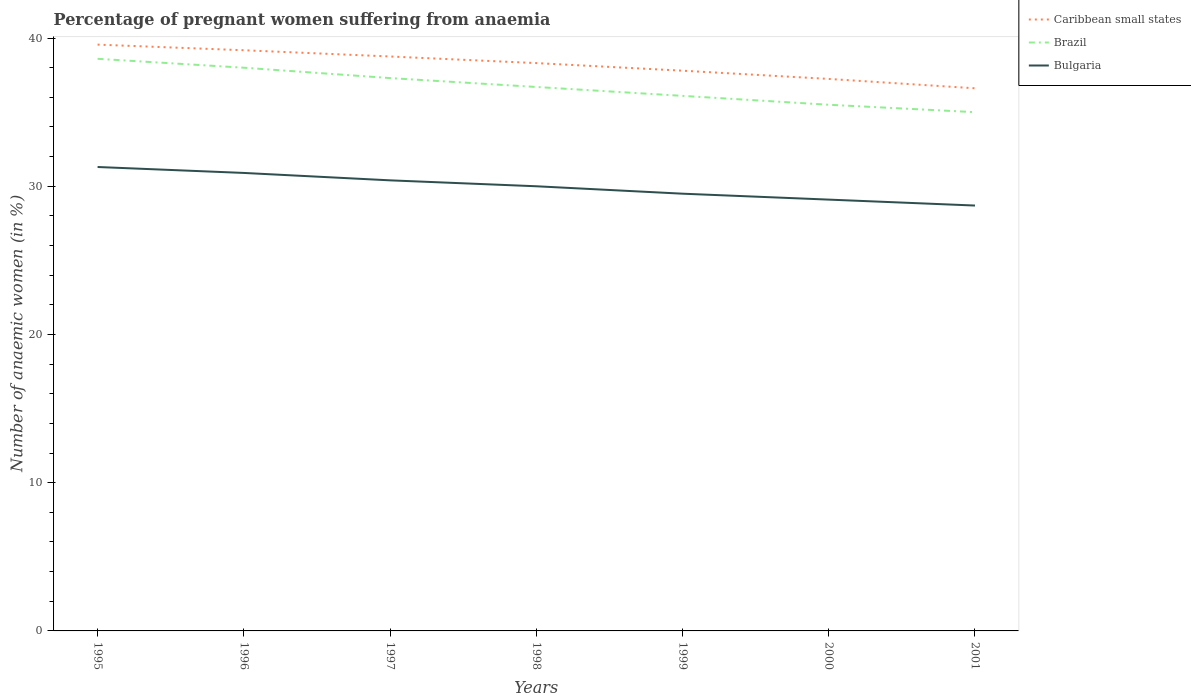How many different coloured lines are there?
Keep it short and to the point. 3. Across all years, what is the maximum number of anaemic women in Bulgaria?
Your response must be concise. 28.7. What is the total number of anaemic women in Bulgaria in the graph?
Provide a short and direct response. 1.8. What is the difference between the highest and the second highest number of anaemic women in Caribbean small states?
Make the answer very short. 2.95. How many years are there in the graph?
Your answer should be very brief. 7. Are the values on the major ticks of Y-axis written in scientific E-notation?
Ensure brevity in your answer.  No. What is the title of the graph?
Offer a terse response. Percentage of pregnant women suffering from anaemia. Does "San Marino" appear as one of the legend labels in the graph?
Offer a terse response. No. What is the label or title of the X-axis?
Offer a very short reply. Years. What is the label or title of the Y-axis?
Ensure brevity in your answer.  Number of anaemic women (in %). What is the Number of anaemic women (in %) in Caribbean small states in 1995?
Give a very brief answer. 39.56. What is the Number of anaemic women (in %) of Brazil in 1995?
Offer a terse response. 38.6. What is the Number of anaemic women (in %) in Bulgaria in 1995?
Ensure brevity in your answer.  31.3. What is the Number of anaemic women (in %) of Caribbean small states in 1996?
Ensure brevity in your answer.  39.18. What is the Number of anaemic women (in %) in Brazil in 1996?
Keep it short and to the point. 38. What is the Number of anaemic women (in %) in Bulgaria in 1996?
Offer a very short reply. 30.9. What is the Number of anaemic women (in %) in Caribbean small states in 1997?
Make the answer very short. 38.76. What is the Number of anaemic women (in %) in Brazil in 1997?
Offer a terse response. 37.3. What is the Number of anaemic women (in %) in Bulgaria in 1997?
Offer a terse response. 30.4. What is the Number of anaemic women (in %) in Caribbean small states in 1998?
Your response must be concise. 38.31. What is the Number of anaemic women (in %) of Brazil in 1998?
Keep it short and to the point. 36.7. What is the Number of anaemic women (in %) in Bulgaria in 1998?
Keep it short and to the point. 30. What is the Number of anaemic women (in %) of Caribbean small states in 1999?
Give a very brief answer. 37.8. What is the Number of anaemic women (in %) in Brazil in 1999?
Keep it short and to the point. 36.1. What is the Number of anaemic women (in %) in Bulgaria in 1999?
Offer a terse response. 29.5. What is the Number of anaemic women (in %) in Caribbean small states in 2000?
Offer a very short reply. 37.24. What is the Number of anaemic women (in %) in Brazil in 2000?
Keep it short and to the point. 35.5. What is the Number of anaemic women (in %) of Bulgaria in 2000?
Provide a succinct answer. 29.1. What is the Number of anaemic women (in %) of Caribbean small states in 2001?
Offer a terse response. 36.61. What is the Number of anaemic women (in %) in Brazil in 2001?
Keep it short and to the point. 35. What is the Number of anaemic women (in %) of Bulgaria in 2001?
Make the answer very short. 28.7. Across all years, what is the maximum Number of anaemic women (in %) in Caribbean small states?
Ensure brevity in your answer.  39.56. Across all years, what is the maximum Number of anaemic women (in %) in Brazil?
Make the answer very short. 38.6. Across all years, what is the maximum Number of anaemic women (in %) of Bulgaria?
Your answer should be very brief. 31.3. Across all years, what is the minimum Number of anaemic women (in %) of Caribbean small states?
Keep it short and to the point. 36.61. Across all years, what is the minimum Number of anaemic women (in %) in Bulgaria?
Provide a succinct answer. 28.7. What is the total Number of anaemic women (in %) in Caribbean small states in the graph?
Your answer should be very brief. 267.45. What is the total Number of anaemic women (in %) in Brazil in the graph?
Provide a succinct answer. 257.2. What is the total Number of anaemic women (in %) of Bulgaria in the graph?
Provide a short and direct response. 209.9. What is the difference between the Number of anaemic women (in %) of Caribbean small states in 1995 and that in 1996?
Offer a very short reply. 0.38. What is the difference between the Number of anaemic women (in %) in Brazil in 1995 and that in 1996?
Offer a terse response. 0.6. What is the difference between the Number of anaemic women (in %) in Caribbean small states in 1995 and that in 1997?
Ensure brevity in your answer.  0.8. What is the difference between the Number of anaemic women (in %) of Bulgaria in 1995 and that in 1997?
Provide a succinct answer. 0.9. What is the difference between the Number of anaemic women (in %) of Caribbean small states in 1995 and that in 1998?
Your response must be concise. 1.25. What is the difference between the Number of anaemic women (in %) in Brazil in 1995 and that in 1998?
Your answer should be very brief. 1.9. What is the difference between the Number of anaemic women (in %) of Caribbean small states in 1995 and that in 1999?
Give a very brief answer. 1.76. What is the difference between the Number of anaemic women (in %) of Caribbean small states in 1995 and that in 2000?
Make the answer very short. 2.31. What is the difference between the Number of anaemic women (in %) of Bulgaria in 1995 and that in 2000?
Keep it short and to the point. 2.2. What is the difference between the Number of anaemic women (in %) in Caribbean small states in 1995 and that in 2001?
Your answer should be very brief. 2.95. What is the difference between the Number of anaemic women (in %) of Bulgaria in 1995 and that in 2001?
Your response must be concise. 2.6. What is the difference between the Number of anaemic women (in %) of Caribbean small states in 1996 and that in 1997?
Your answer should be compact. 0.42. What is the difference between the Number of anaemic women (in %) in Caribbean small states in 1996 and that in 1998?
Your answer should be compact. 0.87. What is the difference between the Number of anaemic women (in %) in Brazil in 1996 and that in 1998?
Make the answer very short. 1.3. What is the difference between the Number of anaemic women (in %) in Caribbean small states in 1996 and that in 1999?
Your answer should be compact. 1.38. What is the difference between the Number of anaemic women (in %) of Caribbean small states in 1996 and that in 2000?
Offer a very short reply. 1.93. What is the difference between the Number of anaemic women (in %) of Caribbean small states in 1996 and that in 2001?
Keep it short and to the point. 2.57. What is the difference between the Number of anaemic women (in %) of Brazil in 1996 and that in 2001?
Keep it short and to the point. 3. What is the difference between the Number of anaemic women (in %) in Caribbean small states in 1997 and that in 1998?
Provide a short and direct response. 0.45. What is the difference between the Number of anaemic women (in %) of Brazil in 1997 and that in 1998?
Make the answer very short. 0.6. What is the difference between the Number of anaemic women (in %) in Caribbean small states in 1997 and that in 1999?
Your answer should be compact. 0.96. What is the difference between the Number of anaemic women (in %) of Brazil in 1997 and that in 1999?
Your answer should be very brief. 1.2. What is the difference between the Number of anaemic women (in %) in Caribbean small states in 1997 and that in 2000?
Give a very brief answer. 1.51. What is the difference between the Number of anaemic women (in %) of Brazil in 1997 and that in 2000?
Your answer should be compact. 1.8. What is the difference between the Number of anaemic women (in %) in Bulgaria in 1997 and that in 2000?
Give a very brief answer. 1.3. What is the difference between the Number of anaemic women (in %) of Caribbean small states in 1997 and that in 2001?
Your response must be concise. 2.15. What is the difference between the Number of anaemic women (in %) in Bulgaria in 1997 and that in 2001?
Your answer should be very brief. 1.7. What is the difference between the Number of anaemic women (in %) of Caribbean small states in 1998 and that in 1999?
Provide a succinct answer. 0.51. What is the difference between the Number of anaemic women (in %) of Bulgaria in 1998 and that in 1999?
Provide a succinct answer. 0.5. What is the difference between the Number of anaemic women (in %) of Caribbean small states in 1998 and that in 2000?
Offer a terse response. 1.07. What is the difference between the Number of anaemic women (in %) of Bulgaria in 1998 and that in 2000?
Offer a terse response. 0.9. What is the difference between the Number of anaemic women (in %) in Brazil in 1998 and that in 2001?
Your response must be concise. 1.7. What is the difference between the Number of anaemic women (in %) of Bulgaria in 1998 and that in 2001?
Provide a short and direct response. 1.3. What is the difference between the Number of anaemic women (in %) in Caribbean small states in 1999 and that in 2000?
Offer a very short reply. 0.56. What is the difference between the Number of anaemic women (in %) of Caribbean small states in 1999 and that in 2001?
Offer a very short reply. 1.19. What is the difference between the Number of anaemic women (in %) of Bulgaria in 1999 and that in 2001?
Offer a very short reply. 0.8. What is the difference between the Number of anaemic women (in %) of Caribbean small states in 2000 and that in 2001?
Make the answer very short. 0.63. What is the difference between the Number of anaemic women (in %) in Bulgaria in 2000 and that in 2001?
Provide a succinct answer. 0.4. What is the difference between the Number of anaemic women (in %) in Caribbean small states in 1995 and the Number of anaemic women (in %) in Brazil in 1996?
Ensure brevity in your answer.  1.56. What is the difference between the Number of anaemic women (in %) in Caribbean small states in 1995 and the Number of anaemic women (in %) in Bulgaria in 1996?
Your answer should be very brief. 8.66. What is the difference between the Number of anaemic women (in %) in Brazil in 1995 and the Number of anaemic women (in %) in Bulgaria in 1996?
Your response must be concise. 7.7. What is the difference between the Number of anaemic women (in %) of Caribbean small states in 1995 and the Number of anaemic women (in %) of Brazil in 1997?
Make the answer very short. 2.26. What is the difference between the Number of anaemic women (in %) of Caribbean small states in 1995 and the Number of anaemic women (in %) of Bulgaria in 1997?
Offer a very short reply. 9.16. What is the difference between the Number of anaemic women (in %) of Brazil in 1995 and the Number of anaemic women (in %) of Bulgaria in 1997?
Your response must be concise. 8.2. What is the difference between the Number of anaemic women (in %) in Caribbean small states in 1995 and the Number of anaemic women (in %) in Brazil in 1998?
Keep it short and to the point. 2.86. What is the difference between the Number of anaemic women (in %) of Caribbean small states in 1995 and the Number of anaemic women (in %) of Bulgaria in 1998?
Offer a terse response. 9.56. What is the difference between the Number of anaemic women (in %) in Caribbean small states in 1995 and the Number of anaemic women (in %) in Brazil in 1999?
Offer a terse response. 3.46. What is the difference between the Number of anaemic women (in %) in Caribbean small states in 1995 and the Number of anaemic women (in %) in Bulgaria in 1999?
Keep it short and to the point. 10.06. What is the difference between the Number of anaemic women (in %) of Brazil in 1995 and the Number of anaemic women (in %) of Bulgaria in 1999?
Provide a succinct answer. 9.1. What is the difference between the Number of anaemic women (in %) in Caribbean small states in 1995 and the Number of anaemic women (in %) in Brazil in 2000?
Your answer should be compact. 4.06. What is the difference between the Number of anaemic women (in %) in Caribbean small states in 1995 and the Number of anaemic women (in %) in Bulgaria in 2000?
Your response must be concise. 10.46. What is the difference between the Number of anaemic women (in %) of Brazil in 1995 and the Number of anaemic women (in %) of Bulgaria in 2000?
Offer a terse response. 9.5. What is the difference between the Number of anaemic women (in %) in Caribbean small states in 1995 and the Number of anaemic women (in %) in Brazil in 2001?
Offer a terse response. 4.56. What is the difference between the Number of anaemic women (in %) in Caribbean small states in 1995 and the Number of anaemic women (in %) in Bulgaria in 2001?
Provide a short and direct response. 10.86. What is the difference between the Number of anaemic women (in %) in Caribbean small states in 1996 and the Number of anaemic women (in %) in Brazil in 1997?
Your response must be concise. 1.88. What is the difference between the Number of anaemic women (in %) of Caribbean small states in 1996 and the Number of anaemic women (in %) of Bulgaria in 1997?
Keep it short and to the point. 8.78. What is the difference between the Number of anaemic women (in %) in Caribbean small states in 1996 and the Number of anaemic women (in %) in Brazil in 1998?
Provide a succinct answer. 2.48. What is the difference between the Number of anaemic women (in %) of Caribbean small states in 1996 and the Number of anaemic women (in %) of Bulgaria in 1998?
Provide a succinct answer. 9.18. What is the difference between the Number of anaemic women (in %) of Caribbean small states in 1996 and the Number of anaemic women (in %) of Brazil in 1999?
Keep it short and to the point. 3.08. What is the difference between the Number of anaemic women (in %) of Caribbean small states in 1996 and the Number of anaemic women (in %) of Bulgaria in 1999?
Provide a short and direct response. 9.68. What is the difference between the Number of anaemic women (in %) in Brazil in 1996 and the Number of anaemic women (in %) in Bulgaria in 1999?
Offer a very short reply. 8.5. What is the difference between the Number of anaemic women (in %) of Caribbean small states in 1996 and the Number of anaemic women (in %) of Brazil in 2000?
Give a very brief answer. 3.68. What is the difference between the Number of anaemic women (in %) of Caribbean small states in 1996 and the Number of anaemic women (in %) of Bulgaria in 2000?
Keep it short and to the point. 10.08. What is the difference between the Number of anaemic women (in %) in Brazil in 1996 and the Number of anaemic women (in %) in Bulgaria in 2000?
Make the answer very short. 8.9. What is the difference between the Number of anaemic women (in %) of Caribbean small states in 1996 and the Number of anaemic women (in %) of Brazil in 2001?
Your answer should be compact. 4.18. What is the difference between the Number of anaemic women (in %) of Caribbean small states in 1996 and the Number of anaemic women (in %) of Bulgaria in 2001?
Offer a very short reply. 10.48. What is the difference between the Number of anaemic women (in %) in Caribbean small states in 1997 and the Number of anaemic women (in %) in Brazil in 1998?
Make the answer very short. 2.06. What is the difference between the Number of anaemic women (in %) of Caribbean small states in 1997 and the Number of anaemic women (in %) of Bulgaria in 1998?
Your response must be concise. 8.76. What is the difference between the Number of anaemic women (in %) of Brazil in 1997 and the Number of anaemic women (in %) of Bulgaria in 1998?
Give a very brief answer. 7.3. What is the difference between the Number of anaemic women (in %) in Caribbean small states in 1997 and the Number of anaemic women (in %) in Brazil in 1999?
Make the answer very short. 2.66. What is the difference between the Number of anaemic women (in %) of Caribbean small states in 1997 and the Number of anaemic women (in %) of Bulgaria in 1999?
Provide a short and direct response. 9.26. What is the difference between the Number of anaemic women (in %) of Caribbean small states in 1997 and the Number of anaemic women (in %) of Brazil in 2000?
Your answer should be compact. 3.26. What is the difference between the Number of anaemic women (in %) of Caribbean small states in 1997 and the Number of anaemic women (in %) of Bulgaria in 2000?
Ensure brevity in your answer.  9.66. What is the difference between the Number of anaemic women (in %) of Brazil in 1997 and the Number of anaemic women (in %) of Bulgaria in 2000?
Ensure brevity in your answer.  8.2. What is the difference between the Number of anaemic women (in %) of Caribbean small states in 1997 and the Number of anaemic women (in %) of Brazil in 2001?
Offer a terse response. 3.76. What is the difference between the Number of anaemic women (in %) of Caribbean small states in 1997 and the Number of anaemic women (in %) of Bulgaria in 2001?
Offer a very short reply. 10.06. What is the difference between the Number of anaemic women (in %) in Brazil in 1997 and the Number of anaemic women (in %) in Bulgaria in 2001?
Make the answer very short. 8.6. What is the difference between the Number of anaemic women (in %) in Caribbean small states in 1998 and the Number of anaemic women (in %) in Brazil in 1999?
Make the answer very short. 2.21. What is the difference between the Number of anaemic women (in %) of Caribbean small states in 1998 and the Number of anaemic women (in %) of Bulgaria in 1999?
Give a very brief answer. 8.81. What is the difference between the Number of anaemic women (in %) in Brazil in 1998 and the Number of anaemic women (in %) in Bulgaria in 1999?
Your answer should be compact. 7.2. What is the difference between the Number of anaemic women (in %) in Caribbean small states in 1998 and the Number of anaemic women (in %) in Brazil in 2000?
Keep it short and to the point. 2.81. What is the difference between the Number of anaemic women (in %) of Caribbean small states in 1998 and the Number of anaemic women (in %) of Bulgaria in 2000?
Provide a short and direct response. 9.21. What is the difference between the Number of anaemic women (in %) of Caribbean small states in 1998 and the Number of anaemic women (in %) of Brazil in 2001?
Keep it short and to the point. 3.31. What is the difference between the Number of anaemic women (in %) in Caribbean small states in 1998 and the Number of anaemic women (in %) in Bulgaria in 2001?
Provide a succinct answer. 9.61. What is the difference between the Number of anaemic women (in %) of Caribbean small states in 1999 and the Number of anaemic women (in %) of Brazil in 2000?
Your response must be concise. 2.3. What is the difference between the Number of anaemic women (in %) of Caribbean small states in 1999 and the Number of anaemic women (in %) of Bulgaria in 2000?
Offer a terse response. 8.7. What is the difference between the Number of anaemic women (in %) of Caribbean small states in 1999 and the Number of anaemic women (in %) of Brazil in 2001?
Your response must be concise. 2.8. What is the difference between the Number of anaemic women (in %) in Caribbean small states in 1999 and the Number of anaemic women (in %) in Bulgaria in 2001?
Keep it short and to the point. 9.1. What is the difference between the Number of anaemic women (in %) of Caribbean small states in 2000 and the Number of anaemic women (in %) of Brazil in 2001?
Make the answer very short. 2.24. What is the difference between the Number of anaemic women (in %) of Caribbean small states in 2000 and the Number of anaemic women (in %) of Bulgaria in 2001?
Keep it short and to the point. 8.54. What is the average Number of anaemic women (in %) of Caribbean small states per year?
Your answer should be compact. 38.21. What is the average Number of anaemic women (in %) of Brazil per year?
Keep it short and to the point. 36.74. What is the average Number of anaemic women (in %) in Bulgaria per year?
Give a very brief answer. 29.99. In the year 1995, what is the difference between the Number of anaemic women (in %) of Caribbean small states and Number of anaemic women (in %) of Bulgaria?
Keep it short and to the point. 8.26. In the year 1995, what is the difference between the Number of anaemic women (in %) in Brazil and Number of anaemic women (in %) in Bulgaria?
Your answer should be compact. 7.3. In the year 1996, what is the difference between the Number of anaemic women (in %) of Caribbean small states and Number of anaemic women (in %) of Brazil?
Offer a terse response. 1.18. In the year 1996, what is the difference between the Number of anaemic women (in %) of Caribbean small states and Number of anaemic women (in %) of Bulgaria?
Give a very brief answer. 8.28. In the year 1996, what is the difference between the Number of anaemic women (in %) of Brazil and Number of anaemic women (in %) of Bulgaria?
Your answer should be compact. 7.1. In the year 1997, what is the difference between the Number of anaemic women (in %) in Caribbean small states and Number of anaemic women (in %) in Brazil?
Keep it short and to the point. 1.46. In the year 1997, what is the difference between the Number of anaemic women (in %) of Caribbean small states and Number of anaemic women (in %) of Bulgaria?
Offer a very short reply. 8.36. In the year 1998, what is the difference between the Number of anaemic women (in %) in Caribbean small states and Number of anaemic women (in %) in Brazil?
Provide a succinct answer. 1.61. In the year 1998, what is the difference between the Number of anaemic women (in %) of Caribbean small states and Number of anaemic women (in %) of Bulgaria?
Provide a short and direct response. 8.31. In the year 1999, what is the difference between the Number of anaemic women (in %) in Caribbean small states and Number of anaemic women (in %) in Brazil?
Ensure brevity in your answer.  1.7. In the year 1999, what is the difference between the Number of anaemic women (in %) of Caribbean small states and Number of anaemic women (in %) of Bulgaria?
Provide a succinct answer. 8.3. In the year 1999, what is the difference between the Number of anaemic women (in %) in Brazil and Number of anaemic women (in %) in Bulgaria?
Keep it short and to the point. 6.6. In the year 2000, what is the difference between the Number of anaemic women (in %) in Caribbean small states and Number of anaemic women (in %) in Brazil?
Ensure brevity in your answer.  1.74. In the year 2000, what is the difference between the Number of anaemic women (in %) in Caribbean small states and Number of anaemic women (in %) in Bulgaria?
Provide a succinct answer. 8.14. In the year 2001, what is the difference between the Number of anaemic women (in %) in Caribbean small states and Number of anaemic women (in %) in Brazil?
Your response must be concise. 1.61. In the year 2001, what is the difference between the Number of anaemic women (in %) in Caribbean small states and Number of anaemic women (in %) in Bulgaria?
Offer a very short reply. 7.91. What is the ratio of the Number of anaemic women (in %) of Caribbean small states in 1995 to that in 1996?
Your answer should be compact. 1.01. What is the ratio of the Number of anaemic women (in %) in Brazil in 1995 to that in 1996?
Keep it short and to the point. 1.02. What is the ratio of the Number of anaemic women (in %) of Bulgaria in 1995 to that in 1996?
Provide a succinct answer. 1.01. What is the ratio of the Number of anaemic women (in %) in Caribbean small states in 1995 to that in 1997?
Provide a succinct answer. 1.02. What is the ratio of the Number of anaemic women (in %) in Brazil in 1995 to that in 1997?
Offer a very short reply. 1.03. What is the ratio of the Number of anaemic women (in %) of Bulgaria in 1995 to that in 1997?
Provide a short and direct response. 1.03. What is the ratio of the Number of anaemic women (in %) in Caribbean small states in 1995 to that in 1998?
Offer a very short reply. 1.03. What is the ratio of the Number of anaemic women (in %) in Brazil in 1995 to that in 1998?
Offer a terse response. 1.05. What is the ratio of the Number of anaemic women (in %) in Bulgaria in 1995 to that in 1998?
Give a very brief answer. 1.04. What is the ratio of the Number of anaemic women (in %) of Caribbean small states in 1995 to that in 1999?
Give a very brief answer. 1.05. What is the ratio of the Number of anaemic women (in %) of Brazil in 1995 to that in 1999?
Keep it short and to the point. 1.07. What is the ratio of the Number of anaemic women (in %) of Bulgaria in 1995 to that in 1999?
Your answer should be very brief. 1.06. What is the ratio of the Number of anaemic women (in %) of Caribbean small states in 1995 to that in 2000?
Your response must be concise. 1.06. What is the ratio of the Number of anaemic women (in %) of Brazil in 1995 to that in 2000?
Your response must be concise. 1.09. What is the ratio of the Number of anaemic women (in %) of Bulgaria in 1995 to that in 2000?
Make the answer very short. 1.08. What is the ratio of the Number of anaemic women (in %) of Caribbean small states in 1995 to that in 2001?
Offer a very short reply. 1.08. What is the ratio of the Number of anaemic women (in %) in Brazil in 1995 to that in 2001?
Keep it short and to the point. 1.1. What is the ratio of the Number of anaemic women (in %) of Bulgaria in 1995 to that in 2001?
Your answer should be very brief. 1.09. What is the ratio of the Number of anaemic women (in %) in Caribbean small states in 1996 to that in 1997?
Your answer should be very brief. 1.01. What is the ratio of the Number of anaemic women (in %) in Brazil in 1996 to that in 1997?
Provide a succinct answer. 1.02. What is the ratio of the Number of anaemic women (in %) of Bulgaria in 1996 to that in 1997?
Offer a very short reply. 1.02. What is the ratio of the Number of anaemic women (in %) of Caribbean small states in 1996 to that in 1998?
Provide a succinct answer. 1.02. What is the ratio of the Number of anaemic women (in %) in Brazil in 1996 to that in 1998?
Offer a terse response. 1.04. What is the ratio of the Number of anaemic women (in %) in Caribbean small states in 1996 to that in 1999?
Provide a short and direct response. 1.04. What is the ratio of the Number of anaemic women (in %) in Brazil in 1996 to that in 1999?
Your answer should be compact. 1.05. What is the ratio of the Number of anaemic women (in %) in Bulgaria in 1996 to that in 1999?
Keep it short and to the point. 1.05. What is the ratio of the Number of anaemic women (in %) of Caribbean small states in 1996 to that in 2000?
Give a very brief answer. 1.05. What is the ratio of the Number of anaemic women (in %) in Brazil in 1996 to that in 2000?
Your response must be concise. 1.07. What is the ratio of the Number of anaemic women (in %) of Bulgaria in 1996 to that in 2000?
Make the answer very short. 1.06. What is the ratio of the Number of anaemic women (in %) of Caribbean small states in 1996 to that in 2001?
Your answer should be very brief. 1.07. What is the ratio of the Number of anaemic women (in %) in Brazil in 1996 to that in 2001?
Ensure brevity in your answer.  1.09. What is the ratio of the Number of anaemic women (in %) of Bulgaria in 1996 to that in 2001?
Ensure brevity in your answer.  1.08. What is the ratio of the Number of anaemic women (in %) in Caribbean small states in 1997 to that in 1998?
Provide a short and direct response. 1.01. What is the ratio of the Number of anaemic women (in %) of Brazil in 1997 to that in 1998?
Offer a very short reply. 1.02. What is the ratio of the Number of anaemic women (in %) of Bulgaria in 1997 to that in 1998?
Make the answer very short. 1.01. What is the ratio of the Number of anaemic women (in %) of Caribbean small states in 1997 to that in 1999?
Your answer should be very brief. 1.03. What is the ratio of the Number of anaemic women (in %) of Brazil in 1997 to that in 1999?
Your answer should be very brief. 1.03. What is the ratio of the Number of anaemic women (in %) in Bulgaria in 1997 to that in 1999?
Offer a very short reply. 1.03. What is the ratio of the Number of anaemic women (in %) of Caribbean small states in 1997 to that in 2000?
Your answer should be compact. 1.04. What is the ratio of the Number of anaemic women (in %) of Brazil in 1997 to that in 2000?
Give a very brief answer. 1.05. What is the ratio of the Number of anaemic women (in %) in Bulgaria in 1997 to that in 2000?
Your answer should be compact. 1.04. What is the ratio of the Number of anaemic women (in %) of Caribbean small states in 1997 to that in 2001?
Provide a succinct answer. 1.06. What is the ratio of the Number of anaemic women (in %) of Brazil in 1997 to that in 2001?
Ensure brevity in your answer.  1.07. What is the ratio of the Number of anaemic women (in %) in Bulgaria in 1997 to that in 2001?
Provide a succinct answer. 1.06. What is the ratio of the Number of anaemic women (in %) in Caribbean small states in 1998 to that in 1999?
Provide a succinct answer. 1.01. What is the ratio of the Number of anaemic women (in %) in Brazil in 1998 to that in 1999?
Provide a succinct answer. 1.02. What is the ratio of the Number of anaemic women (in %) in Bulgaria in 1998 to that in 1999?
Make the answer very short. 1.02. What is the ratio of the Number of anaemic women (in %) in Caribbean small states in 1998 to that in 2000?
Your answer should be compact. 1.03. What is the ratio of the Number of anaemic women (in %) of Brazil in 1998 to that in 2000?
Make the answer very short. 1.03. What is the ratio of the Number of anaemic women (in %) in Bulgaria in 1998 to that in 2000?
Your answer should be compact. 1.03. What is the ratio of the Number of anaemic women (in %) of Caribbean small states in 1998 to that in 2001?
Keep it short and to the point. 1.05. What is the ratio of the Number of anaemic women (in %) of Brazil in 1998 to that in 2001?
Keep it short and to the point. 1.05. What is the ratio of the Number of anaemic women (in %) of Bulgaria in 1998 to that in 2001?
Provide a short and direct response. 1.05. What is the ratio of the Number of anaemic women (in %) in Caribbean small states in 1999 to that in 2000?
Offer a very short reply. 1.01. What is the ratio of the Number of anaemic women (in %) in Brazil in 1999 to that in 2000?
Keep it short and to the point. 1.02. What is the ratio of the Number of anaemic women (in %) in Bulgaria in 1999 to that in 2000?
Provide a succinct answer. 1.01. What is the ratio of the Number of anaemic women (in %) of Caribbean small states in 1999 to that in 2001?
Provide a succinct answer. 1.03. What is the ratio of the Number of anaemic women (in %) in Brazil in 1999 to that in 2001?
Give a very brief answer. 1.03. What is the ratio of the Number of anaemic women (in %) in Bulgaria in 1999 to that in 2001?
Provide a short and direct response. 1.03. What is the ratio of the Number of anaemic women (in %) of Caribbean small states in 2000 to that in 2001?
Make the answer very short. 1.02. What is the ratio of the Number of anaemic women (in %) in Brazil in 2000 to that in 2001?
Keep it short and to the point. 1.01. What is the ratio of the Number of anaemic women (in %) in Bulgaria in 2000 to that in 2001?
Your answer should be compact. 1.01. What is the difference between the highest and the second highest Number of anaemic women (in %) in Caribbean small states?
Your response must be concise. 0.38. What is the difference between the highest and the second highest Number of anaemic women (in %) in Brazil?
Keep it short and to the point. 0.6. What is the difference between the highest and the second highest Number of anaemic women (in %) of Bulgaria?
Give a very brief answer. 0.4. What is the difference between the highest and the lowest Number of anaemic women (in %) in Caribbean small states?
Your answer should be very brief. 2.95. What is the difference between the highest and the lowest Number of anaemic women (in %) of Brazil?
Make the answer very short. 3.6. What is the difference between the highest and the lowest Number of anaemic women (in %) in Bulgaria?
Make the answer very short. 2.6. 